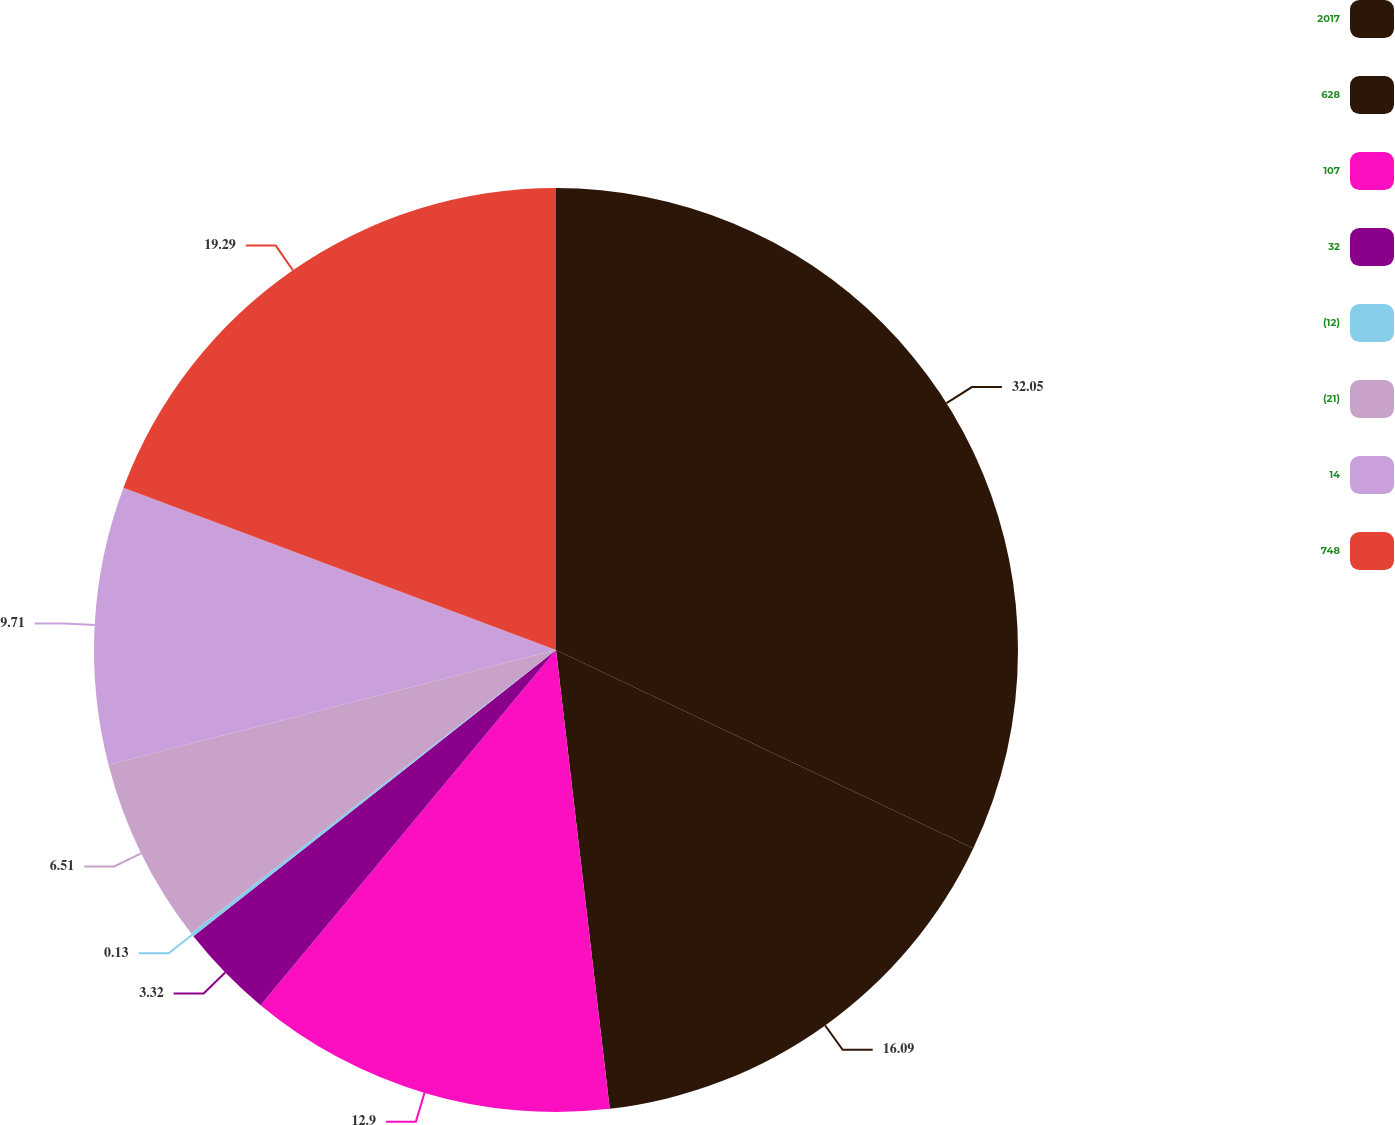Convert chart to OTSL. <chart><loc_0><loc_0><loc_500><loc_500><pie_chart><fcel>2017<fcel>628<fcel>107<fcel>32<fcel>(12)<fcel>(21)<fcel>14<fcel>748<nl><fcel>32.06%<fcel>16.09%<fcel>12.9%<fcel>3.32%<fcel>0.13%<fcel>6.51%<fcel>9.71%<fcel>19.29%<nl></chart> 